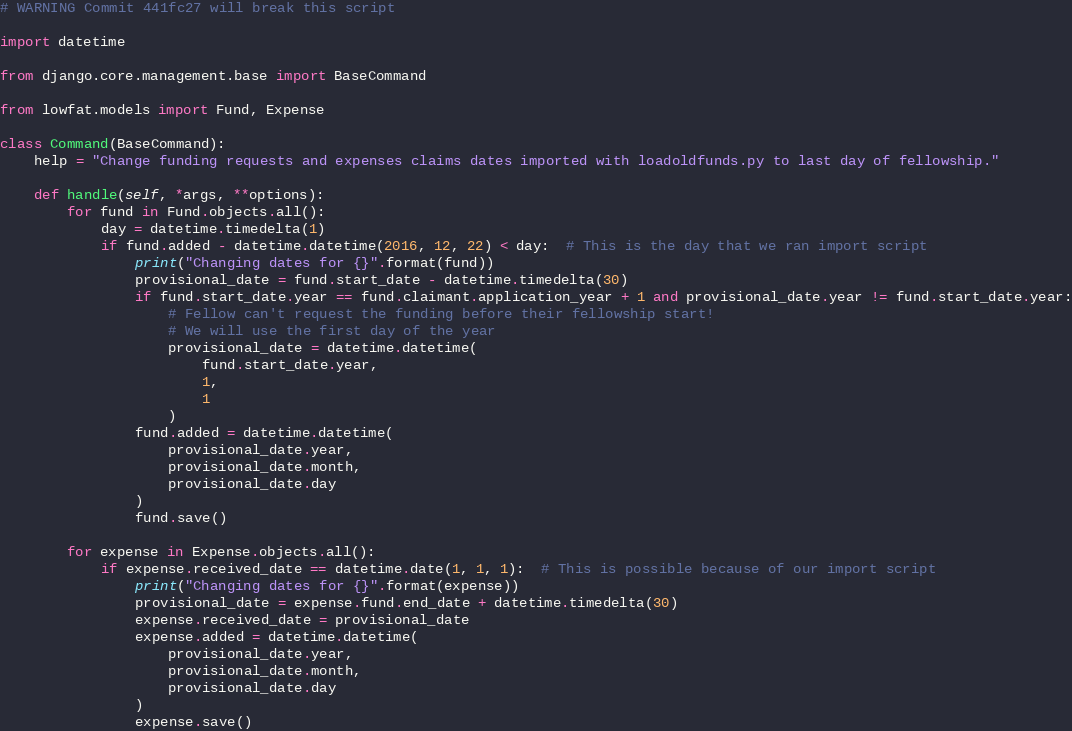<code> <loc_0><loc_0><loc_500><loc_500><_Python_># WARNING Commit 441fc27 will break this script

import datetime

from django.core.management.base import BaseCommand

from lowfat.models import Fund, Expense

class Command(BaseCommand):
    help = "Change funding requests and expenses claims dates imported with loadoldfunds.py to last day of fellowship."

    def handle(self, *args, **options):
        for fund in Fund.objects.all():
            day = datetime.timedelta(1)
            if fund.added - datetime.datetime(2016, 12, 22) < day:  # This is the day that we ran import script
                print("Changing dates for {}".format(fund))
                provisional_date = fund.start_date - datetime.timedelta(30)
                if fund.start_date.year == fund.claimant.application_year + 1 and provisional_date.year != fund.start_date.year:
                    # Fellow can't request the funding before their fellowship start!
                    # We will use the first day of the year
                    provisional_date = datetime.datetime(
                        fund.start_date.year,
                        1,
                        1
                    )
                fund.added = datetime.datetime(
                    provisional_date.year,
                    provisional_date.month,
                    provisional_date.day
                )
                fund.save()

        for expense in Expense.objects.all():
            if expense.received_date == datetime.date(1, 1, 1):  # This is possible because of our import script
                print("Changing dates for {}".format(expense))
                provisional_date = expense.fund.end_date + datetime.timedelta(30)
                expense.received_date = provisional_date
                expense.added = datetime.datetime(
                    provisional_date.year,
                    provisional_date.month,
                    provisional_date.day
                )
                expense.save()
</code> 